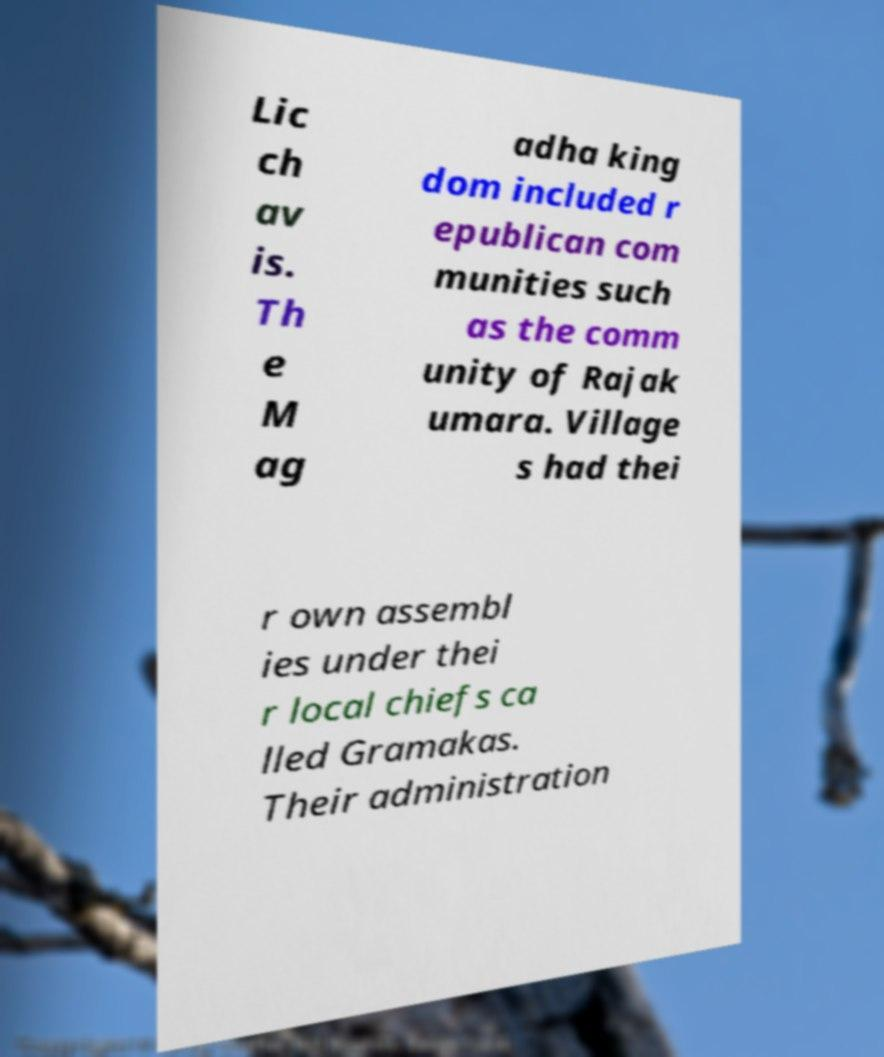What messages or text are displayed in this image? I need them in a readable, typed format. Lic ch av is. Th e M ag adha king dom included r epublican com munities such as the comm unity of Rajak umara. Village s had thei r own assembl ies under thei r local chiefs ca lled Gramakas. Their administration 